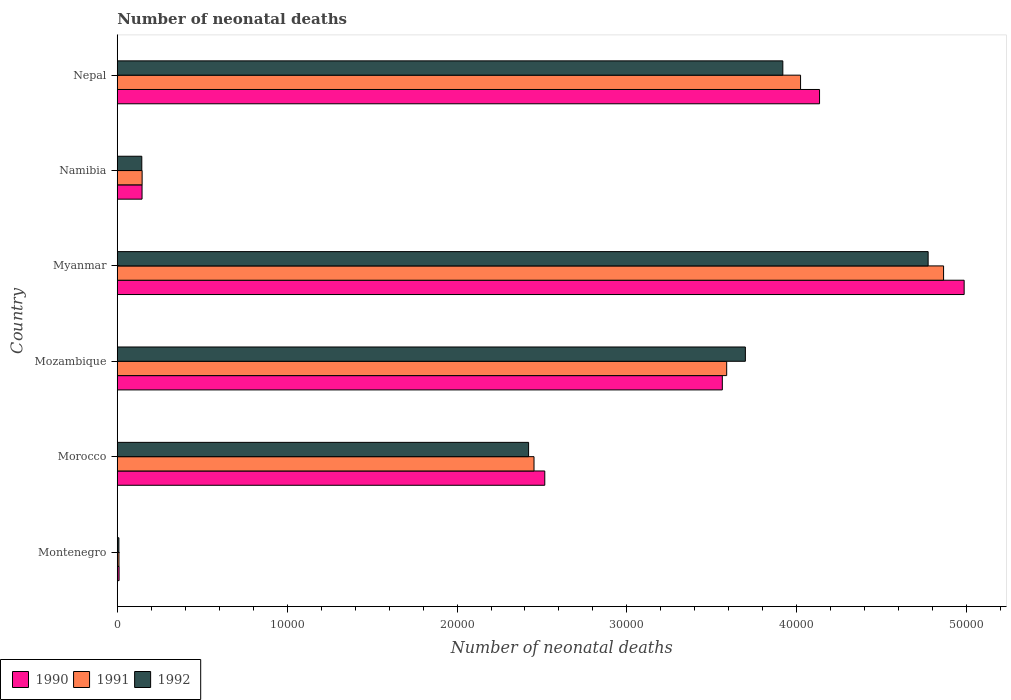How many different coloured bars are there?
Offer a very short reply. 3. How many groups of bars are there?
Your response must be concise. 6. Are the number of bars per tick equal to the number of legend labels?
Provide a succinct answer. Yes. Are the number of bars on each tick of the Y-axis equal?
Provide a short and direct response. Yes. How many bars are there on the 1st tick from the bottom?
Make the answer very short. 3. What is the label of the 4th group of bars from the top?
Offer a terse response. Mozambique. What is the number of neonatal deaths in in 1990 in Morocco?
Offer a terse response. 2.52e+04. Across all countries, what is the maximum number of neonatal deaths in in 1992?
Give a very brief answer. 4.77e+04. Across all countries, what is the minimum number of neonatal deaths in in 1992?
Your response must be concise. 95. In which country was the number of neonatal deaths in in 1992 maximum?
Keep it short and to the point. Myanmar. In which country was the number of neonatal deaths in in 1991 minimum?
Your answer should be very brief. Montenegro. What is the total number of neonatal deaths in in 1990 in the graph?
Your response must be concise. 1.54e+05. What is the difference between the number of neonatal deaths in in 1992 in Morocco and that in Mozambique?
Your answer should be very brief. -1.28e+04. What is the difference between the number of neonatal deaths in in 1992 in Myanmar and the number of neonatal deaths in in 1990 in Mozambique?
Your answer should be compact. 1.21e+04. What is the average number of neonatal deaths in in 1991 per country?
Provide a short and direct response. 2.51e+04. What is the difference between the number of neonatal deaths in in 1991 and number of neonatal deaths in in 1990 in Mozambique?
Your answer should be very brief. 256. In how many countries, is the number of neonatal deaths in in 1990 greater than 28000 ?
Offer a terse response. 3. What is the ratio of the number of neonatal deaths in in 1991 in Morocco to that in Mozambique?
Your response must be concise. 0.68. What is the difference between the highest and the second highest number of neonatal deaths in in 1991?
Ensure brevity in your answer.  8419. What is the difference between the highest and the lowest number of neonatal deaths in in 1992?
Give a very brief answer. 4.76e+04. In how many countries, is the number of neonatal deaths in in 1992 greater than the average number of neonatal deaths in in 1992 taken over all countries?
Keep it short and to the point. 3. What does the 1st bar from the bottom in Morocco represents?
Your answer should be very brief. 1990. Is it the case that in every country, the sum of the number of neonatal deaths in in 1990 and number of neonatal deaths in in 1992 is greater than the number of neonatal deaths in in 1991?
Offer a very short reply. Yes. Are all the bars in the graph horizontal?
Provide a succinct answer. Yes. How many countries are there in the graph?
Provide a succinct answer. 6. Are the values on the major ticks of X-axis written in scientific E-notation?
Give a very brief answer. No. Does the graph contain any zero values?
Provide a succinct answer. No. Where does the legend appear in the graph?
Your response must be concise. Bottom left. How many legend labels are there?
Keep it short and to the point. 3. What is the title of the graph?
Offer a terse response. Number of neonatal deaths. What is the label or title of the X-axis?
Offer a terse response. Number of neonatal deaths. What is the label or title of the Y-axis?
Make the answer very short. Country. What is the Number of neonatal deaths of 1990 in Montenegro?
Provide a short and direct response. 106. What is the Number of neonatal deaths in 1991 in Montenegro?
Keep it short and to the point. 99. What is the Number of neonatal deaths of 1990 in Morocco?
Your answer should be compact. 2.52e+04. What is the Number of neonatal deaths in 1991 in Morocco?
Your answer should be compact. 2.45e+04. What is the Number of neonatal deaths of 1992 in Morocco?
Your answer should be very brief. 2.42e+04. What is the Number of neonatal deaths of 1990 in Mozambique?
Give a very brief answer. 3.56e+04. What is the Number of neonatal deaths of 1991 in Mozambique?
Keep it short and to the point. 3.59e+04. What is the Number of neonatal deaths of 1992 in Mozambique?
Keep it short and to the point. 3.70e+04. What is the Number of neonatal deaths of 1990 in Myanmar?
Keep it short and to the point. 4.99e+04. What is the Number of neonatal deaths of 1991 in Myanmar?
Offer a very short reply. 4.86e+04. What is the Number of neonatal deaths of 1992 in Myanmar?
Make the answer very short. 4.77e+04. What is the Number of neonatal deaths in 1990 in Namibia?
Give a very brief answer. 1458. What is the Number of neonatal deaths in 1991 in Namibia?
Your answer should be very brief. 1462. What is the Number of neonatal deaths in 1992 in Namibia?
Offer a terse response. 1443. What is the Number of neonatal deaths of 1990 in Nepal?
Your response must be concise. 4.13e+04. What is the Number of neonatal deaths in 1991 in Nepal?
Provide a short and direct response. 4.02e+04. What is the Number of neonatal deaths in 1992 in Nepal?
Your response must be concise. 3.92e+04. Across all countries, what is the maximum Number of neonatal deaths of 1990?
Make the answer very short. 4.99e+04. Across all countries, what is the maximum Number of neonatal deaths of 1991?
Your response must be concise. 4.86e+04. Across all countries, what is the maximum Number of neonatal deaths of 1992?
Your response must be concise. 4.77e+04. Across all countries, what is the minimum Number of neonatal deaths of 1990?
Provide a succinct answer. 106. Across all countries, what is the minimum Number of neonatal deaths of 1992?
Provide a succinct answer. 95. What is the total Number of neonatal deaths of 1990 in the graph?
Ensure brevity in your answer.  1.54e+05. What is the total Number of neonatal deaths in 1991 in the graph?
Give a very brief answer. 1.51e+05. What is the total Number of neonatal deaths in 1992 in the graph?
Make the answer very short. 1.50e+05. What is the difference between the Number of neonatal deaths in 1990 in Montenegro and that in Morocco?
Make the answer very short. -2.51e+04. What is the difference between the Number of neonatal deaths in 1991 in Montenegro and that in Morocco?
Ensure brevity in your answer.  -2.44e+04. What is the difference between the Number of neonatal deaths in 1992 in Montenegro and that in Morocco?
Your answer should be compact. -2.41e+04. What is the difference between the Number of neonatal deaths in 1990 in Montenegro and that in Mozambique?
Your response must be concise. -3.55e+04. What is the difference between the Number of neonatal deaths of 1991 in Montenegro and that in Mozambique?
Make the answer very short. -3.58e+04. What is the difference between the Number of neonatal deaths of 1992 in Montenegro and that in Mozambique?
Offer a terse response. -3.69e+04. What is the difference between the Number of neonatal deaths in 1990 in Montenegro and that in Myanmar?
Your answer should be compact. -4.97e+04. What is the difference between the Number of neonatal deaths of 1991 in Montenegro and that in Myanmar?
Make the answer very short. -4.85e+04. What is the difference between the Number of neonatal deaths of 1992 in Montenegro and that in Myanmar?
Your answer should be compact. -4.76e+04. What is the difference between the Number of neonatal deaths of 1990 in Montenegro and that in Namibia?
Ensure brevity in your answer.  -1352. What is the difference between the Number of neonatal deaths in 1991 in Montenegro and that in Namibia?
Ensure brevity in your answer.  -1363. What is the difference between the Number of neonatal deaths of 1992 in Montenegro and that in Namibia?
Your response must be concise. -1348. What is the difference between the Number of neonatal deaths in 1990 in Montenegro and that in Nepal?
Make the answer very short. -4.12e+04. What is the difference between the Number of neonatal deaths in 1991 in Montenegro and that in Nepal?
Make the answer very short. -4.01e+04. What is the difference between the Number of neonatal deaths in 1992 in Montenegro and that in Nepal?
Ensure brevity in your answer.  -3.91e+04. What is the difference between the Number of neonatal deaths in 1990 in Morocco and that in Mozambique?
Offer a terse response. -1.05e+04. What is the difference between the Number of neonatal deaths in 1991 in Morocco and that in Mozambique?
Make the answer very short. -1.13e+04. What is the difference between the Number of neonatal deaths of 1992 in Morocco and that in Mozambique?
Give a very brief answer. -1.28e+04. What is the difference between the Number of neonatal deaths in 1990 in Morocco and that in Myanmar?
Ensure brevity in your answer.  -2.47e+04. What is the difference between the Number of neonatal deaths in 1991 in Morocco and that in Myanmar?
Provide a short and direct response. -2.41e+04. What is the difference between the Number of neonatal deaths in 1992 in Morocco and that in Myanmar?
Provide a succinct answer. -2.35e+04. What is the difference between the Number of neonatal deaths of 1990 in Morocco and that in Namibia?
Your response must be concise. 2.37e+04. What is the difference between the Number of neonatal deaths in 1991 in Morocco and that in Namibia?
Ensure brevity in your answer.  2.31e+04. What is the difference between the Number of neonatal deaths of 1992 in Morocco and that in Namibia?
Your answer should be very brief. 2.28e+04. What is the difference between the Number of neonatal deaths of 1990 in Morocco and that in Nepal?
Your response must be concise. -1.62e+04. What is the difference between the Number of neonatal deaths in 1991 in Morocco and that in Nepal?
Your response must be concise. -1.57e+04. What is the difference between the Number of neonatal deaths of 1992 in Morocco and that in Nepal?
Your answer should be very brief. -1.50e+04. What is the difference between the Number of neonatal deaths in 1990 in Mozambique and that in Myanmar?
Ensure brevity in your answer.  -1.42e+04. What is the difference between the Number of neonatal deaths in 1991 in Mozambique and that in Myanmar?
Give a very brief answer. -1.28e+04. What is the difference between the Number of neonatal deaths of 1992 in Mozambique and that in Myanmar?
Offer a terse response. -1.08e+04. What is the difference between the Number of neonatal deaths in 1990 in Mozambique and that in Namibia?
Offer a terse response. 3.42e+04. What is the difference between the Number of neonatal deaths of 1991 in Mozambique and that in Namibia?
Give a very brief answer. 3.44e+04. What is the difference between the Number of neonatal deaths in 1992 in Mozambique and that in Namibia?
Offer a very short reply. 3.55e+04. What is the difference between the Number of neonatal deaths in 1990 in Mozambique and that in Nepal?
Offer a terse response. -5723. What is the difference between the Number of neonatal deaths in 1991 in Mozambique and that in Nepal?
Your answer should be compact. -4349. What is the difference between the Number of neonatal deaths in 1992 in Mozambique and that in Nepal?
Provide a short and direct response. -2205. What is the difference between the Number of neonatal deaths in 1990 in Myanmar and that in Namibia?
Your answer should be very brief. 4.84e+04. What is the difference between the Number of neonatal deaths of 1991 in Myanmar and that in Namibia?
Offer a terse response. 4.72e+04. What is the difference between the Number of neonatal deaths of 1992 in Myanmar and that in Namibia?
Your response must be concise. 4.63e+04. What is the difference between the Number of neonatal deaths in 1990 in Myanmar and that in Nepal?
Make the answer very short. 8512. What is the difference between the Number of neonatal deaths in 1991 in Myanmar and that in Nepal?
Offer a very short reply. 8419. What is the difference between the Number of neonatal deaths in 1992 in Myanmar and that in Nepal?
Provide a short and direct response. 8554. What is the difference between the Number of neonatal deaths of 1990 in Namibia and that in Nepal?
Your answer should be very brief. -3.99e+04. What is the difference between the Number of neonatal deaths of 1991 in Namibia and that in Nepal?
Your answer should be very brief. -3.88e+04. What is the difference between the Number of neonatal deaths in 1992 in Namibia and that in Nepal?
Your answer should be very brief. -3.77e+04. What is the difference between the Number of neonatal deaths of 1990 in Montenegro and the Number of neonatal deaths of 1991 in Morocco?
Ensure brevity in your answer.  -2.44e+04. What is the difference between the Number of neonatal deaths in 1990 in Montenegro and the Number of neonatal deaths in 1992 in Morocco?
Give a very brief answer. -2.41e+04. What is the difference between the Number of neonatal deaths in 1991 in Montenegro and the Number of neonatal deaths in 1992 in Morocco?
Give a very brief answer. -2.41e+04. What is the difference between the Number of neonatal deaths in 1990 in Montenegro and the Number of neonatal deaths in 1991 in Mozambique?
Provide a succinct answer. -3.58e+04. What is the difference between the Number of neonatal deaths of 1990 in Montenegro and the Number of neonatal deaths of 1992 in Mozambique?
Your answer should be compact. -3.69e+04. What is the difference between the Number of neonatal deaths in 1991 in Montenegro and the Number of neonatal deaths in 1992 in Mozambique?
Your answer should be very brief. -3.69e+04. What is the difference between the Number of neonatal deaths of 1990 in Montenegro and the Number of neonatal deaths of 1991 in Myanmar?
Your answer should be compact. -4.85e+04. What is the difference between the Number of neonatal deaths in 1990 in Montenegro and the Number of neonatal deaths in 1992 in Myanmar?
Provide a succinct answer. -4.76e+04. What is the difference between the Number of neonatal deaths of 1991 in Montenegro and the Number of neonatal deaths of 1992 in Myanmar?
Ensure brevity in your answer.  -4.76e+04. What is the difference between the Number of neonatal deaths in 1990 in Montenegro and the Number of neonatal deaths in 1991 in Namibia?
Ensure brevity in your answer.  -1356. What is the difference between the Number of neonatal deaths in 1990 in Montenegro and the Number of neonatal deaths in 1992 in Namibia?
Ensure brevity in your answer.  -1337. What is the difference between the Number of neonatal deaths of 1991 in Montenegro and the Number of neonatal deaths of 1992 in Namibia?
Your response must be concise. -1344. What is the difference between the Number of neonatal deaths of 1990 in Montenegro and the Number of neonatal deaths of 1991 in Nepal?
Give a very brief answer. -4.01e+04. What is the difference between the Number of neonatal deaths of 1990 in Montenegro and the Number of neonatal deaths of 1992 in Nepal?
Give a very brief answer. -3.91e+04. What is the difference between the Number of neonatal deaths of 1991 in Montenegro and the Number of neonatal deaths of 1992 in Nepal?
Your answer should be very brief. -3.91e+04. What is the difference between the Number of neonatal deaths in 1990 in Morocco and the Number of neonatal deaths in 1991 in Mozambique?
Ensure brevity in your answer.  -1.07e+04. What is the difference between the Number of neonatal deaths in 1990 in Morocco and the Number of neonatal deaths in 1992 in Mozambique?
Ensure brevity in your answer.  -1.18e+04. What is the difference between the Number of neonatal deaths of 1991 in Morocco and the Number of neonatal deaths of 1992 in Mozambique?
Offer a terse response. -1.24e+04. What is the difference between the Number of neonatal deaths in 1990 in Morocco and the Number of neonatal deaths in 1991 in Myanmar?
Provide a short and direct response. -2.35e+04. What is the difference between the Number of neonatal deaths in 1990 in Morocco and the Number of neonatal deaths in 1992 in Myanmar?
Provide a short and direct response. -2.26e+04. What is the difference between the Number of neonatal deaths in 1991 in Morocco and the Number of neonatal deaths in 1992 in Myanmar?
Offer a terse response. -2.32e+04. What is the difference between the Number of neonatal deaths of 1990 in Morocco and the Number of neonatal deaths of 1991 in Namibia?
Offer a very short reply. 2.37e+04. What is the difference between the Number of neonatal deaths of 1990 in Morocco and the Number of neonatal deaths of 1992 in Namibia?
Offer a very short reply. 2.37e+04. What is the difference between the Number of neonatal deaths of 1991 in Morocco and the Number of neonatal deaths of 1992 in Namibia?
Your response must be concise. 2.31e+04. What is the difference between the Number of neonatal deaths in 1990 in Morocco and the Number of neonatal deaths in 1991 in Nepal?
Your answer should be very brief. -1.51e+04. What is the difference between the Number of neonatal deaths of 1990 in Morocco and the Number of neonatal deaths of 1992 in Nepal?
Give a very brief answer. -1.40e+04. What is the difference between the Number of neonatal deaths of 1991 in Morocco and the Number of neonatal deaths of 1992 in Nepal?
Offer a very short reply. -1.46e+04. What is the difference between the Number of neonatal deaths of 1990 in Mozambique and the Number of neonatal deaths of 1991 in Myanmar?
Keep it short and to the point. -1.30e+04. What is the difference between the Number of neonatal deaths in 1990 in Mozambique and the Number of neonatal deaths in 1992 in Myanmar?
Make the answer very short. -1.21e+04. What is the difference between the Number of neonatal deaths of 1991 in Mozambique and the Number of neonatal deaths of 1992 in Myanmar?
Make the answer very short. -1.19e+04. What is the difference between the Number of neonatal deaths of 1990 in Mozambique and the Number of neonatal deaths of 1991 in Namibia?
Provide a succinct answer. 3.42e+04. What is the difference between the Number of neonatal deaths in 1990 in Mozambique and the Number of neonatal deaths in 1992 in Namibia?
Provide a short and direct response. 3.42e+04. What is the difference between the Number of neonatal deaths in 1991 in Mozambique and the Number of neonatal deaths in 1992 in Namibia?
Keep it short and to the point. 3.44e+04. What is the difference between the Number of neonatal deaths of 1990 in Mozambique and the Number of neonatal deaths of 1991 in Nepal?
Make the answer very short. -4605. What is the difference between the Number of neonatal deaths of 1990 in Mozambique and the Number of neonatal deaths of 1992 in Nepal?
Ensure brevity in your answer.  -3561. What is the difference between the Number of neonatal deaths in 1991 in Mozambique and the Number of neonatal deaths in 1992 in Nepal?
Offer a terse response. -3305. What is the difference between the Number of neonatal deaths of 1990 in Myanmar and the Number of neonatal deaths of 1991 in Namibia?
Ensure brevity in your answer.  4.84e+04. What is the difference between the Number of neonatal deaths in 1990 in Myanmar and the Number of neonatal deaths in 1992 in Namibia?
Provide a succinct answer. 4.84e+04. What is the difference between the Number of neonatal deaths in 1991 in Myanmar and the Number of neonatal deaths in 1992 in Namibia?
Provide a succinct answer. 4.72e+04. What is the difference between the Number of neonatal deaths in 1990 in Myanmar and the Number of neonatal deaths in 1991 in Nepal?
Make the answer very short. 9630. What is the difference between the Number of neonatal deaths in 1990 in Myanmar and the Number of neonatal deaths in 1992 in Nepal?
Your response must be concise. 1.07e+04. What is the difference between the Number of neonatal deaths of 1991 in Myanmar and the Number of neonatal deaths of 1992 in Nepal?
Offer a terse response. 9463. What is the difference between the Number of neonatal deaths in 1990 in Namibia and the Number of neonatal deaths in 1991 in Nepal?
Offer a very short reply. -3.88e+04. What is the difference between the Number of neonatal deaths in 1990 in Namibia and the Number of neonatal deaths in 1992 in Nepal?
Your response must be concise. -3.77e+04. What is the difference between the Number of neonatal deaths in 1991 in Namibia and the Number of neonatal deaths in 1992 in Nepal?
Make the answer very short. -3.77e+04. What is the average Number of neonatal deaths of 1990 per country?
Make the answer very short. 2.56e+04. What is the average Number of neonatal deaths in 1991 per country?
Your response must be concise. 2.51e+04. What is the average Number of neonatal deaths of 1992 per country?
Your response must be concise. 2.49e+04. What is the difference between the Number of neonatal deaths of 1990 and Number of neonatal deaths of 1991 in Montenegro?
Provide a short and direct response. 7. What is the difference between the Number of neonatal deaths of 1991 and Number of neonatal deaths of 1992 in Montenegro?
Give a very brief answer. 4. What is the difference between the Number of neonatal deaths in 1990 and Number of neonatal deaths in 1991 in Morocco?
Make the answer very short. 634. What is the difference between the Number of neonatal deaths in 1990 and Number of neonatal deaths in 1992 in Morocco?
Keep it short and to the point. 953. What is the difference between the Number of neonatal deaths of 1991 and Number of neonatal deaths of 1992 in Morocco?
Your response must be concise. 319. What is the difference between the Number of neonatal deaths in 1990 and Number of neonatal deaths in 1991 in Mozambique?
Make the answer very short. -256. What is the difference between the Number of neonatal deaths in 1990 and Number of neonatal deaths in 1992 in Mozambique?
Provide a short and direct response. -1356. What is the difference between the Number of neonatal deaths of 1991 and Number of neonatal deaths of 1992 in Mozambique?
Offer a very short reply. -1100. What is the difference between the Number of neonatal deaths in 1990 and Number of neonatal deaths in 1991 in Myanmar?
Keep it short and to the point. 1211. What is the difference between the Number of neonatal deaths of 1990 and Number of neonatal deaths of 1992 in Myanmar?
Offer a terse response. 2120. What is the difference between the Number of neonatal deaths in 1991 and Number of neonatal deaths in 1992 in Myanmar?
Provide a succinct answer. 909. What is the difference between the Number of neonatal deaths in 1990 and Number of neonatal deaths in 1991 in Namibia?
Your response must be concise. -4. What is the difference between the Number of neonatal deaths of 1990 and Number of neonatal deaths of 1991 in Nepal?
Your answer should be very brief. 1118. What is the difference between the Number of neonatal deaths in 1990 and Number of neonatal deaths in 1992 in Nepal?
Provide a succinct answer. 2162. What is the difference between the Number of neonatal deaths of 1991 and Number of neonatal deaths of 1992 in Nepal?
Your answer should be very brief. 1044. What is the ratio of the Number of neonatal deaths of 1990 in Montenegro to that in Morocco?
Offer a very short reply. 0. What is the ratio of the Number of neonatal deaths of 1991 in Montenegro to that in Morocco?
Keep it short and to the point. 0. What is the ratio of the Number of neonatal deaths in 1992 in Montenegro to that in Morocco?
Provide a succinct answer. 0. What is the ratio of the Number of neonatal deaths in 1990 in Montenegro to that in Mozambique?
Provide a succinct answer. 0. What is the ratio of the Number of neonatal deaths in 1991 in Montenegro to that in Mozambique?
Provide a succinct answer. 0. What is the ratio of the Number of neonatal deaths in 1992 in Montenegro to that in Mozambique?
Your response must be concise. 0. What is the ratio of the Number of neonatal deaths in 1990 in Montenegro to that in Myanmar?
Make the answer very short. 0. What is the ratio of the Number of neonatal deaths of 1991 in Montenegro to that in Myanmar?
Give a very brief answer. 0. What is the ratio of the Number of neonatal deaths in 1992 in Montenegro to that in Myanmar?
Offer a very short reply. 0. What is the ratio of the Number of neonatal deaths in 1990 in Montenegro to that in Namibia?
Provide a short and direct response. 0.07. What is the ratio of the Number of neonatal deaths of 1991 in Montenegro to that in Namibia?
Provide a short and direct response. 0.07. What is the ratio of the Number of neonatal deaths of 1992 in Montenegro to that in Namibia?
Your answer should be very brief. 0.07. What is the ratio of the Number of neonatal deaths in 1990 in Montenegro to that in Nepal?
Your answer should be very brief. 0. What is the ratio of the Number of neonatal deaths in 1991 in Montenegro to that in Nepal?
Your answer should be very brief. 0. What is the ratio of the Number of neonatal deaths in 1992 in Montenegro to that in Nepal?
Your response must be concise. 0. What is the ratio of the Number of neonatal deaths of 1990 in Morocco to that in Mozambique?
Offer a very short reply. 0.71. What is the ratio of the Number of neonatal deaths of 1991 in Morocco to that in Mozambique?
Keep it short and to the point. 0.68. What is the ratio of the Number of neonatal deaths of 1992 in Morocco to that in Mozambique?
Ensure brevity in your answer.  0.65. What is the ratio of the Number of neonatal deaths in 1990 in Morocco to that in Myanmar?
Your response must be concise. 0.5. What is the ratio of the Number of neonatal deaths in 1991 in Morocco to that in Myanmar?
Ensure brevity in your answer.  0.5. What is the ratio of the Number of neonatal deaths in 1992 in Morocco to that in Myanmar?
Keep it short and to the point. 0.51. What is the ratio of the Number of neonatal deaths of 1990 in Morocco to that in Namibia?
Give a very brief answer. 17.26. What is the ratio of the Number of neonatal deaths of 1991 in Morocco to that in Namibia?
Offer a very short reply. 16.78. What is the ratio of the Number of neonatal deaths in 1992 in Morocco to that in Namibia?
Your response must be concise. 16.78. What is the ratio of the Number of neonatal deaths of 1990 in Morocco to that in Nepal?
Provide a succinct answer. 0.61. What is the ratio of the Number of neonatal deaths in 1991 in Morocco to that in Nepal?
Give a very brief answer. 0.61. What is the ratio of the Number of neonatal deaths of 1992 in Morocco to that in Nepal?
Your answer should be compact. 0.62. What is the ratio of the Number of neonatal deaths in 1990 in Mozambique to that in Myanmar?
Offer a very short reply. 0.71. What is the ratio of the Number of neonatal deaths in 1991 in Mozambique to that in Myanmar?
Offer a very short reply. 0.74. What is the ratio of the Number of neonatal deaths of 1992 in Mozambique to that in Myanmar?
Keep it short and to the point. 0.77. What is the ratio of the Number of neonatal deaths in 1990 in Mozambique to that in Namibia?
Offer a terse response. 24.43. What is the ratio of the Number of neonatal deaths of 1991 in Mozambique to that in Namibia?
Provide a succinct answer. 24.54. What is the ratio of the Number of neonatal deaths of 1992 in Mozambique to that in Namibia?
Offer a very short reply. 25.62. What is the ratio of the Number of neonatal deaths of 1990 in Mozambique to that in Nepal?
Your answer should be compact. 0.86. What is the ratio of the Number of neonatal deaths of 1991 in Mozambique to that in Nepal?
Your response must be concise. 0.89. What is the ratio of the Number of neonatal deaths in 1992 in Mozambique to that in Nepal?
Offer a very short reply. 0.94. What is the ratio of the Number of neonatal deaths of 1990 in Myanmar to that in Namibia?
Ensure brevity in your answer.  34.19. What is the ratio of the Number of neonatal deaths in 1991 in Myanmar to that in Namibia?
Ensure brevity in your answer.  33.27. What is the ratio of the Number of neonatal deaths in 1992 in Myanmar to that in Namibia?
Give a very brief answer. 33.08. What is the ratio of the Number of neonatal deaths of 1990 in Myanmar to that in Nepal?
Provide a short and direct response. 1.21. What is the ratio of the Number of neonatal deaths of 1991 in Myanmar to that in Nepal?
Provide a succinct answer. 1.21. What is the ratio of the Number of neonatal deaths in 1992 in Myanmar to that in Nepal?
Keep it short and to the point. 1.22. What is the ratio of the Number of neonatal deaths in 1990 in Namibia to that in Nepal?
Give a very brief answer. 0.04. What is the ratio of the Number of neonatal deaths in 1991 in Namibia to that in Nepal?
Provide a short and direct response. 0.04. What is the ratio of the Number of neonatal deaths in 1992 in Namibia to that in Nepal?
Keep it short and to the point. 0.04. What is the difference between the highest and the second highest Number of neonatal deaths in 1990?
Give a very brief answer. 8512. What is the difference between the highest and the second highest Number of neonatal deaths in 1991?
Your answer should be very brief. 8419. What is the difference between the highest and the second highest Number of neonatal deaths of 1992?
Your answer should be compact. 8554. What is the difference between the highest and the lowest Number of neonatal deaths in 1990?
Make the answer very short. 4.97e+04. What is the difference between the highest and the lowest Number of neonatal deaths of 1991?
Ensure brevity in your answer.  4.85e+04. What is the difference between the highest and the lowest Number of neonatal deaths in 1992?
Your response must be concise. 4.76e+04. 